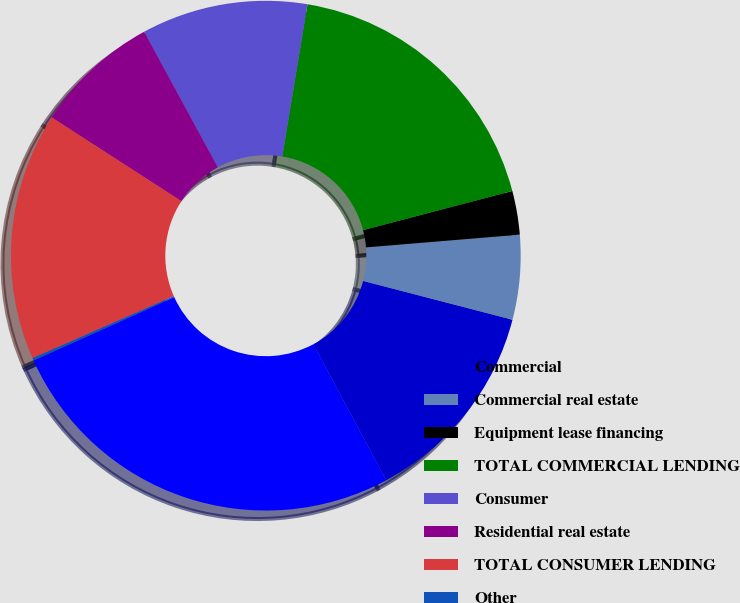Convert chart to OTSL. <chart><loc_0><loc_0><loc_500><loc_500><pie_chart><fcel>Commercial<fcel>Commercial real estate<fcel>Equipment lease financing<fcel>TOTAL COMMERCIAL LENDING<fcel>Consumer<fcel>Residential real estate<fcel>TOTAL CONSUMER LENDING<fcel>Other<fcel>Total loans<nl><fcel>13.12%<fcel>5.36%<fcel>2.77%<fcel>18.3%<fcel>10.54%<fcel>7.95%<fcel>15.71%<fcel>0.18%<fcel>26.07%<nl></chart> 